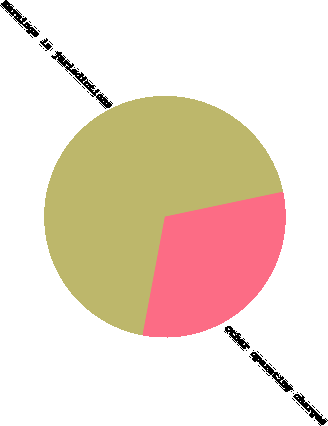Convert chart to OTSL. <chart><loc_0><loc_0><loc_500><loc_500><pie_chart><fcel>Earnings in jurisdictions<fcel>Other operating charges<nl><fcel>68.72%<fcel>31.28%<nl></chart> 